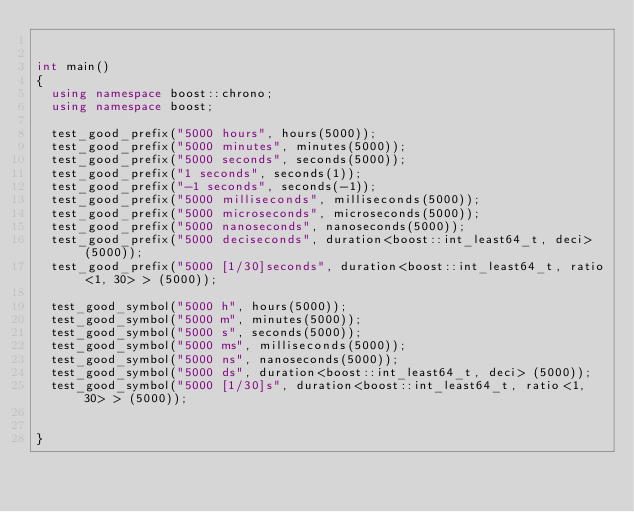<code> <loc_0><loc_0><loc_500><loc_500><_C++_>

int main()
{
  using namespace boost::chrono;
  using namespace boost;

  test_good_prefix("5000 hours", hours(5000));
  test_good_prefix("5000 minutes", minutes(5000));
  test_good_prefix("5000 seconds", seconds(5000));
  test_good_prefix("1 seconds", seconds(1));
  test_good_prefix("-1 seconds", seconds(-1));
  test_good_prefix("5000 milliseconds", milliseconds(5000));
  test_good_prefix("5000 microseconds", microseconds(5000));
  test_good_prefix("5000 nanoseconds", nanoseconds(5000));
  test_good_prefix("5000 deciseconds", duration<boost::int_least64_t, deci> (5000));
  test_good_prefix("5000 [1/30]seconds", duration<boost::int_least64_t, ratio<1, 30> > (5000));

  test_good_symbol("5000 h", hours(5000));
  test_good_symbol("5000 m", minutes(5000));
  test_good_symbol("5000 s", seconds(5000));
  test_good_symbol("5000 ms", milliseconds(5000));
  test_good_symbol("5000 ns", nanoseconds(5000));
  test_good_symbol("5000 ds", duration<boost::int_least64_t, deci> (5000));
  test_good_symbol("5000 [1/30]s", duration<boost::int_least64_t, ratio<1, 30> > (5000));


}

</code> 